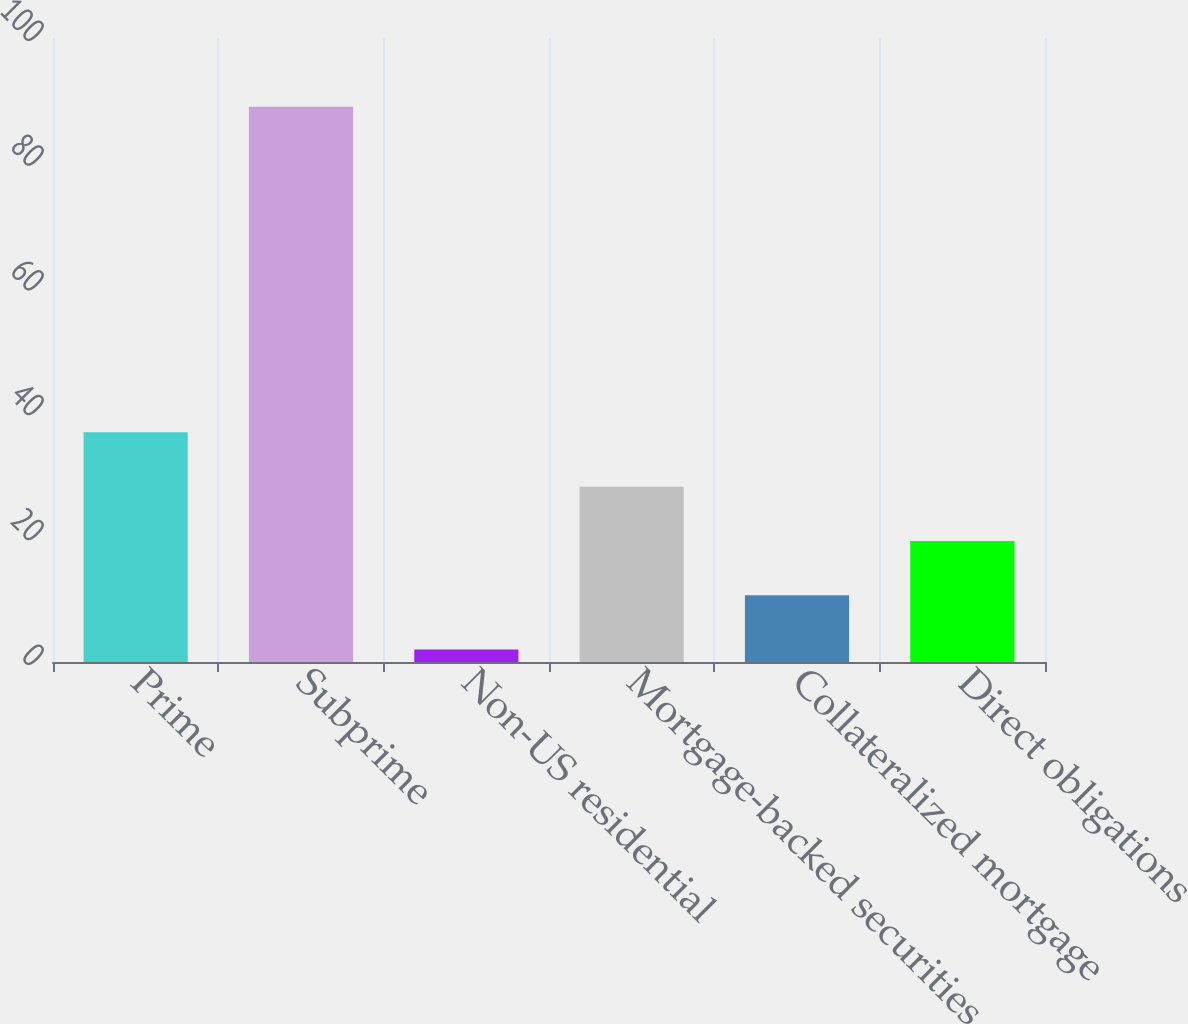<chart> <loc_0><loc_0><loc_500><loc_500><bar_chart><fcel>Prime<fcel>Subprime<fcel>Non-US residential<fcel>Mortgage-backed securities<fcel>Collateralized mortgage<fcel>Direct obligations<nl><fcel>36.8<fcel>89<fcel>2<fcel>28.1<fcel>10.7<fcel>19.4<nl></chart> 